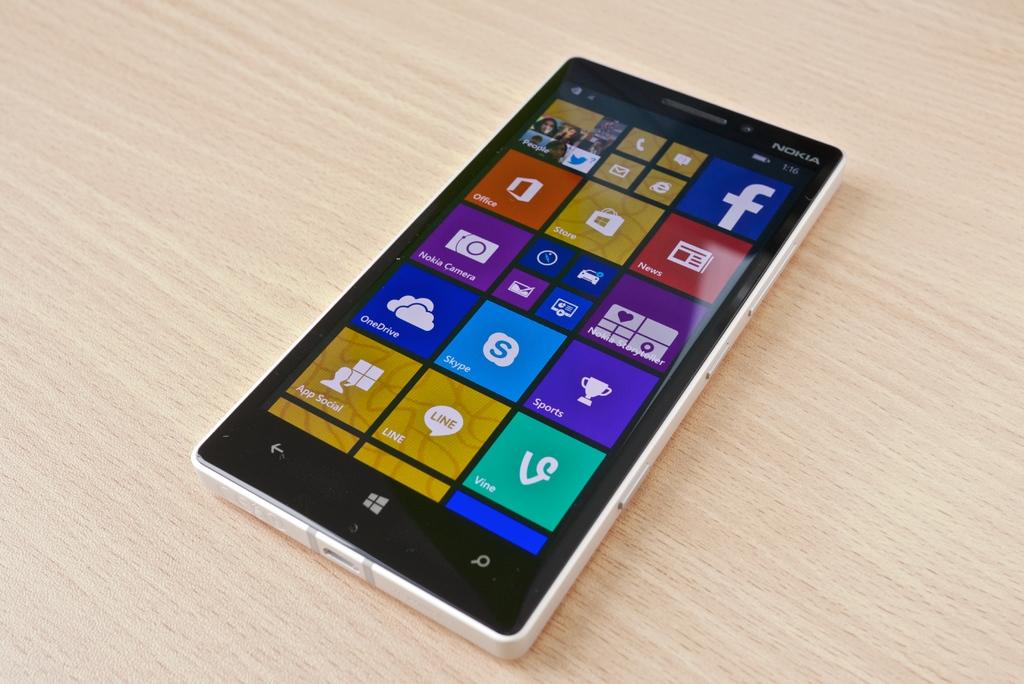What electronic device is present in the image? There is a mobile phone in the image. Where is the mobile phone located? The mobile phone is placed on a table. What can be seen on the mobile phone's screen? There are applications visible on the mobile phone's screen. What is the name of the squirrel sitting on the mobile phone in the image? There is no squirrel present in the image, so it cannot be determined if it has a name. 